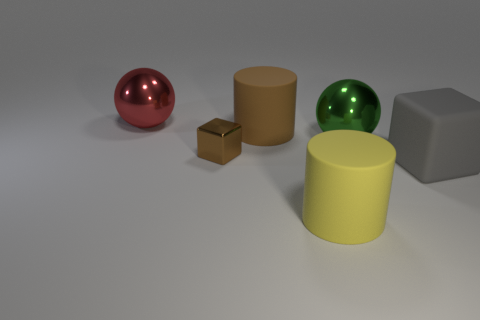What could these objects be used for in a real-world setting? The objects could serve various roles, such as decoration or teaching tools. For example, the spheres might be ornamental, the cylinder and cube could be part of a child's building block set, and the small brown box might be used for packaging or storage.  Are the materials represented by these objects related to each other in any way? Not directly; this collection represents a diversity of materials, each with distinct properties like reflectivity and texture, perhaps meant to highlight how light interacts differently with each surface type. 